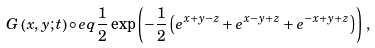<formula> <loc_0><loc_0><loc_500><loc_500>G \left ( x , y ; t \right ) \circ e q \frac { 1 } { 2 } \exp \left ( - \frac { 1 } { 2 } \left ( e ^ { x + y - z } + e ^ { x - y + z } + e ^ { - x + y + z } \right ) \right ) \, ,</formula> 